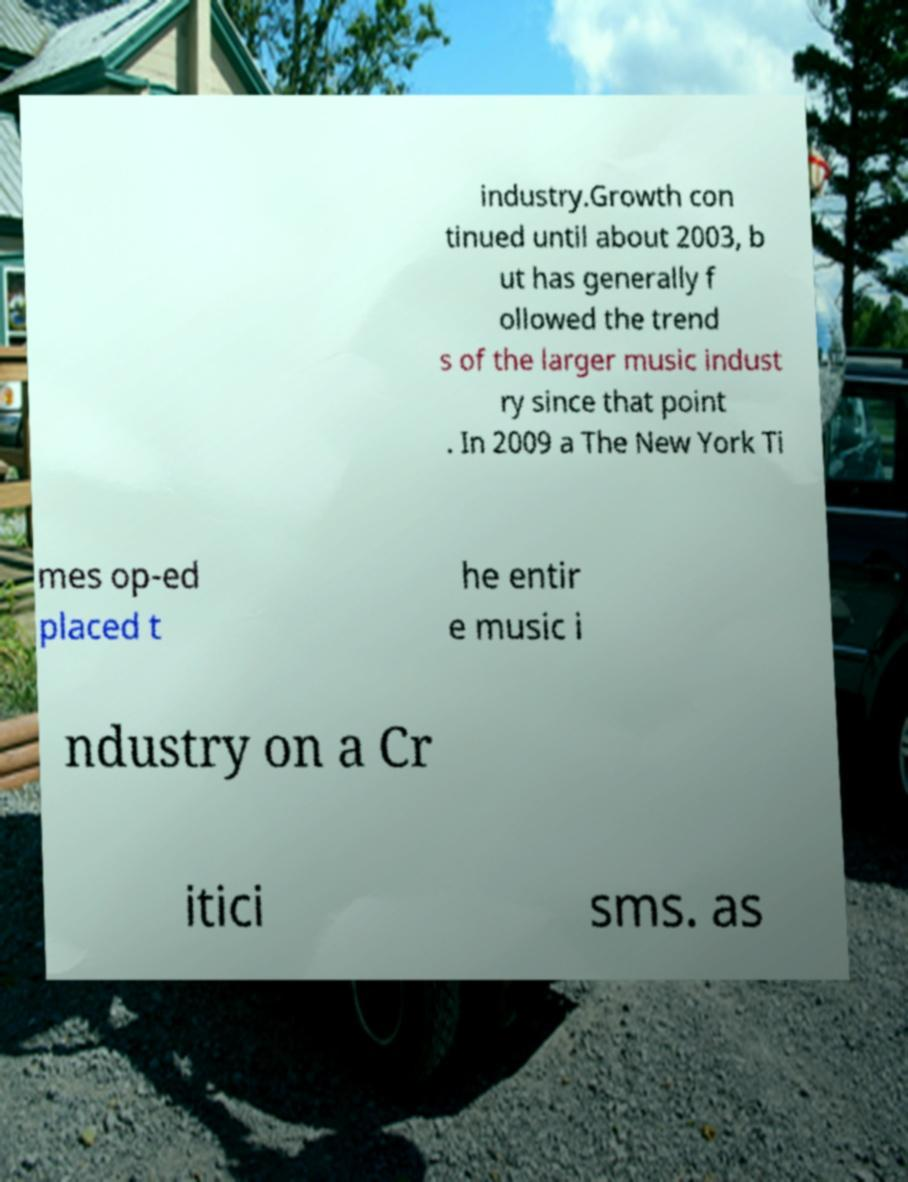I need the written content from this picture converted into text. Can you do that? industry.Growth con tinued until about 2003, b ut has generally f ollowed the trend s of the larger music indust ry since that point . In 2009 a The New York Ti mes op-ed placed t he entir e music i ndustry on a Cr itici sms. as 